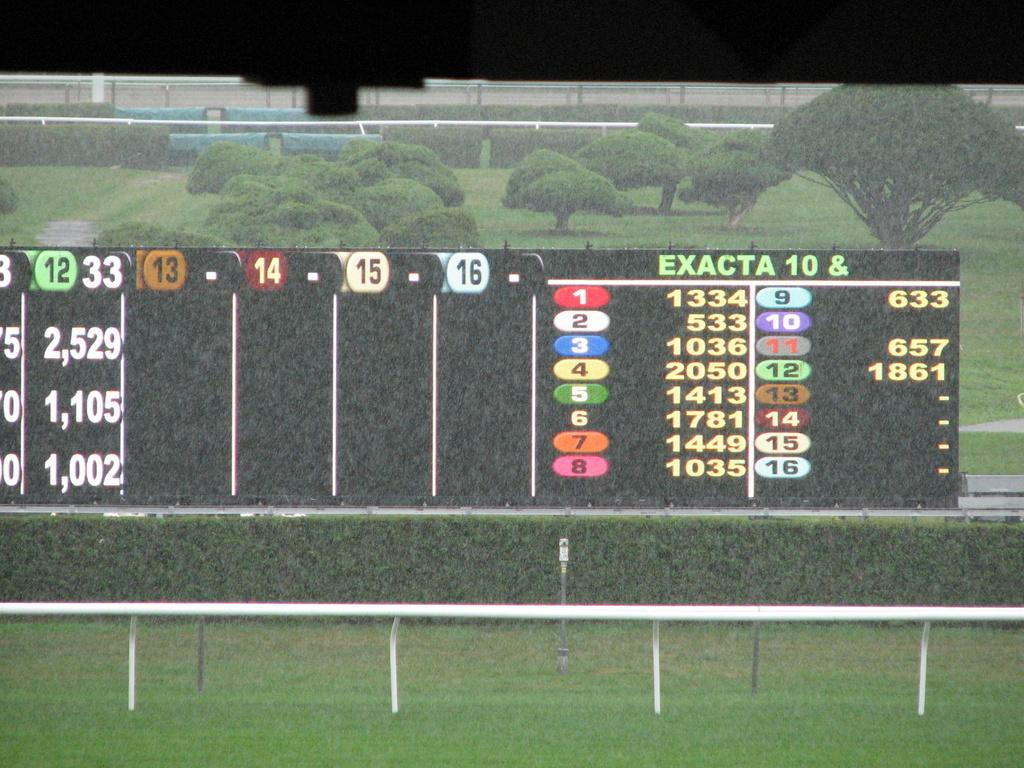<image>
Share a concise interpretation of the image provided. A scoreboard over a sports field says "Exacta 10 &" at the top in green letters. 